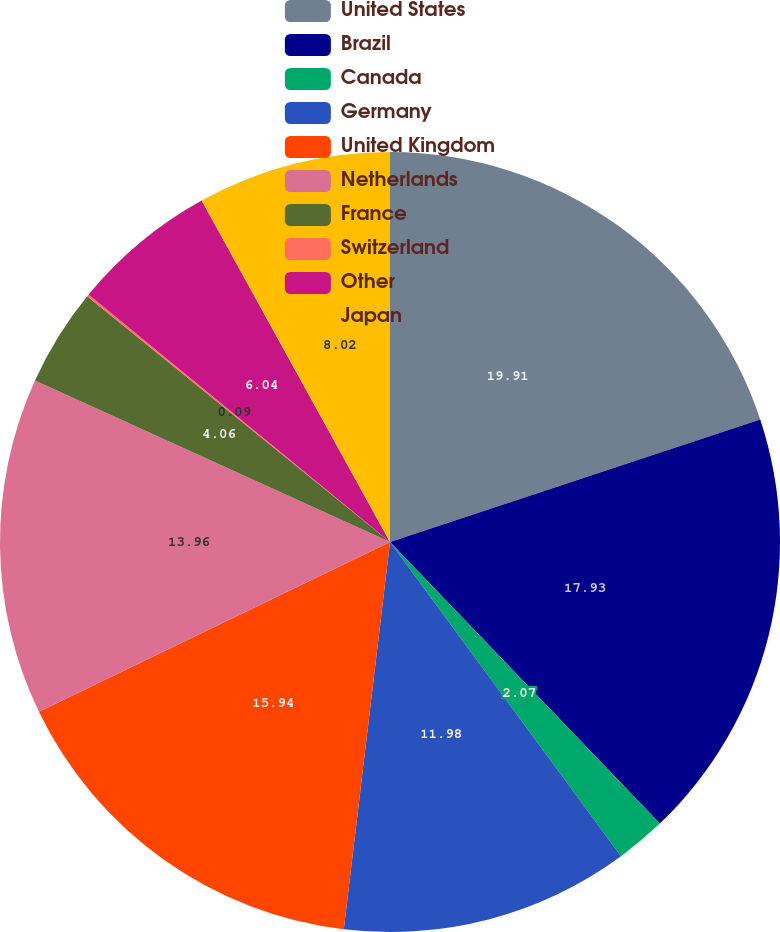Convert chart. <chart><loc_0><loc_0><loc_500><loc_500><pie_chart><fcel>United States<fcel>Brazil<fcel>Canada<fcel>Germany<fcel>United Kingdom<fcel>Netherlands<fcel>France<fcel>Switzerland<fcel>Other<fcel>Japan<nl><fcel>19.91%<fcel>17.93%<fcel>2.07%<fcel>11.98%<fcel>15.94%<fcel>13.96%<fcel>4.06%<fcel>0.09%<fcel>6.04%<fcel>8.02%<nl></chart> 